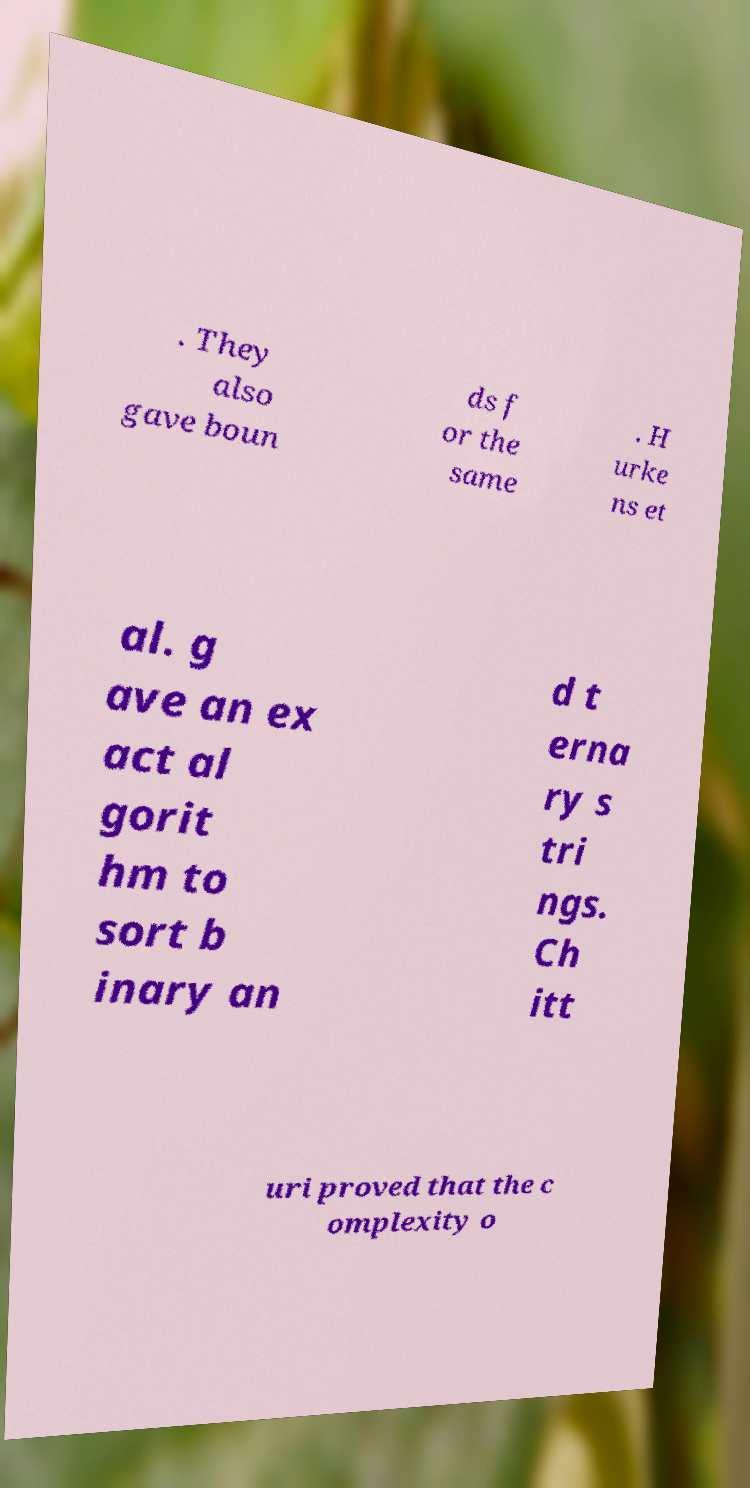Please identify and transcribe the text found in this image. . They also gave boun ds f or the same . H urke ns et al. g ave an ex act al gorit hm to sort b inary an d t erna ry s tri ngs. Ch itt uri proved that the c omplexity o 